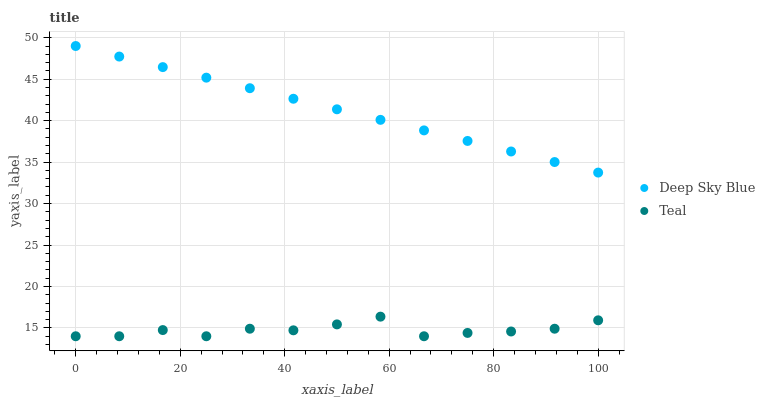Does Teal have the minimum area under the curve?
Answer yes or no. Yes. Does Deep Sky Blue have the maximum area under the curve?
Answer yes or no. Yes. Does Deep Sky Blue have the minimum area under the curve?
Answer yes or no. No. Is Deep Sky Blue the smoothest?
Answer yes or no. Yes. Is Teal the roughest?
Answer yes or no. Yes. Is Deep Sky Blue the roughest?
Answer yes or no. No. Does Teal have the lowest value?
Answer yes or no. Yes. Does Deep Sky Blue have the lowest value?
Answer yes or no. No. Does Deep Sky Blue have the highest value?
Answer yes or no. Yes. Is Teal less than Deep Sky Blue?
Answer yes or no. Yes. Is Deep Sky Blue greater than Teal?
Answer yes or no. Yes. Does Teal intersect Deep Sky Blue?
Answer yes or no. No. 